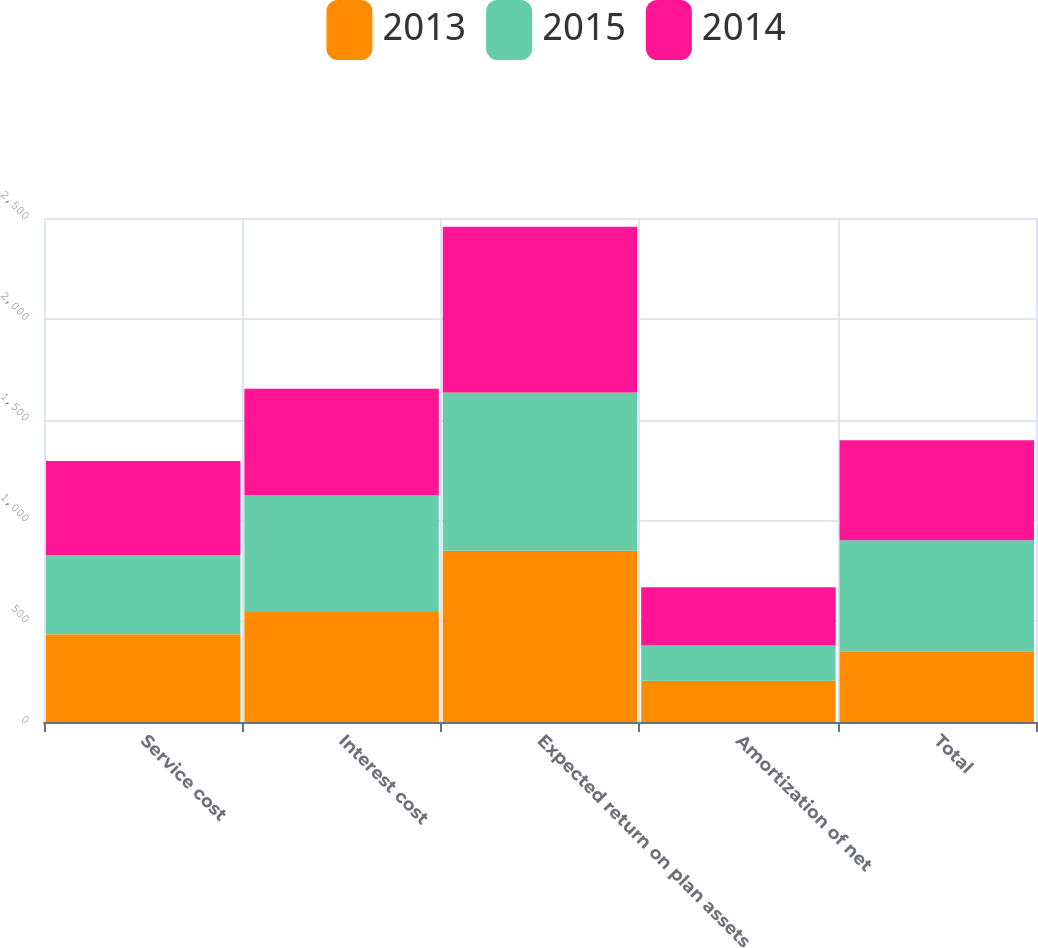<chart> <loc_0><loc_0><loc_500><loc_500><stacked_bar_chart><ecel><fcel>Service cost<fcel>Interest cost<fcel>Expected return on plan assets<fcel>Amortization of net<fcel>Total<nl><fcel>2013<fcel>435<fcel>546<fcel>850<fcel>205<fcel>351<nl><fcel>2015<fcel>393<fcel>580<fcel>784<fcel>175<fcel>550<nl><fcel>2014<fcel>467<fcel>527<fcel>823<fcel>289<fcel>496<nl></chart> 